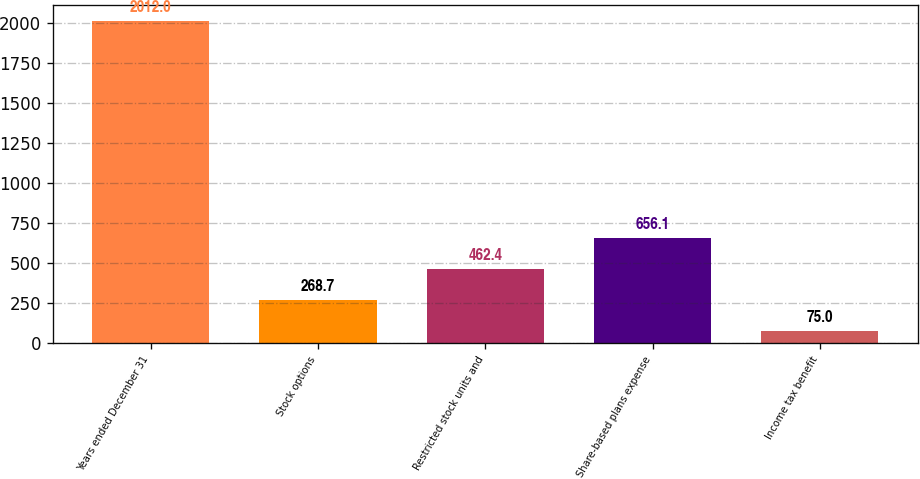Convert chart to OTSL. <chart><loc_0><loc_0><loc_500><loc_500><bar_chart><fcel>Years ended December 31<fcel>Stock options<fcel>Restricted stock units and<fcel>Share-based plans expense<fcel>Income tax benefit<nl><fcel>2012<fcel>268.7<fcel>462.4<fcel>656.1<fcel>75<nl></chart> 